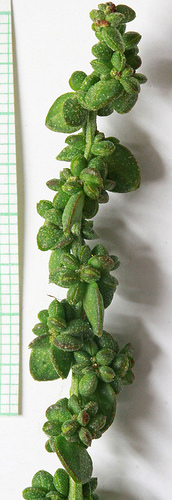<image>
Is there a cactus on the graph paper? No. The cactus is not positioned on the graph paper. They may be near each other, but the cactus is not supported by or resting on top of the graph paper. 